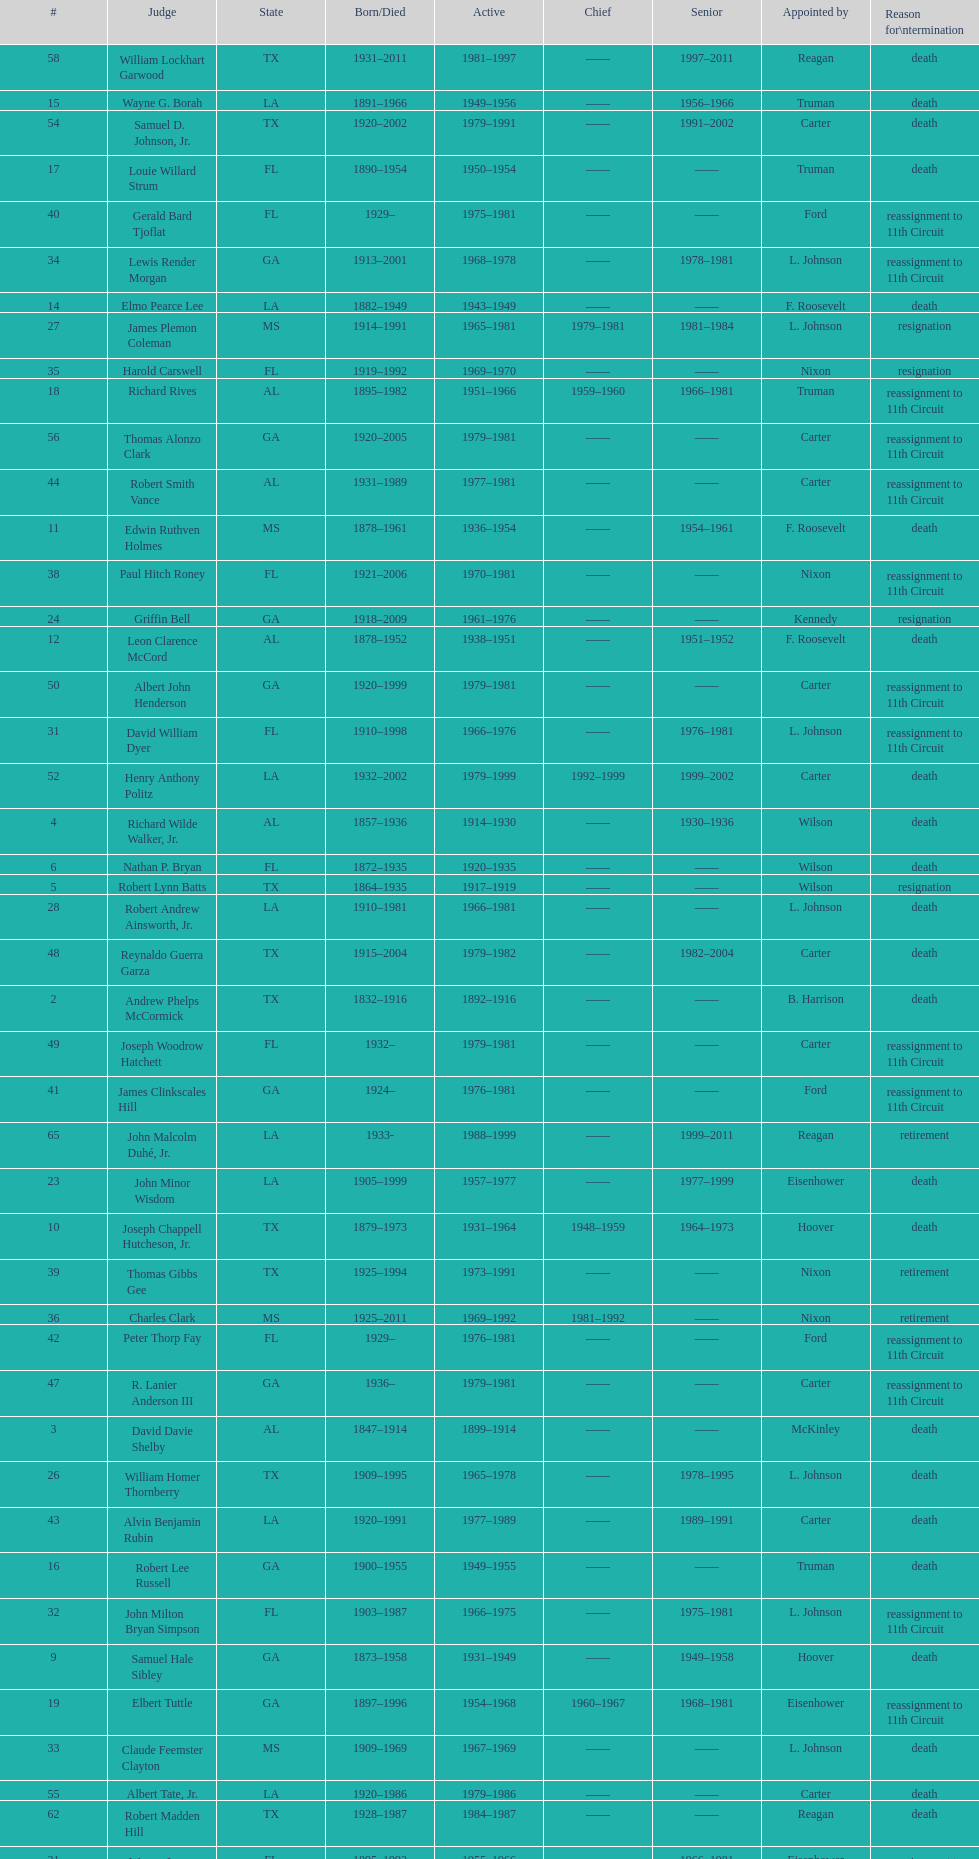Who was the first judge appointed from georgia? Alexander Campbell King. 